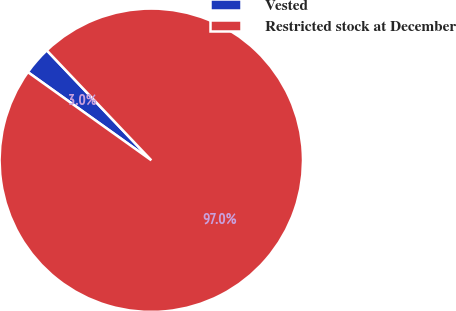Convert chart. <chart><loc_0><loc_0><loc_500><loc_500><pie_chart><fcel>Vested<fcel>Restricted stock at December<nl><fcel>3.03%<fcel>96.97%<nl></chart> 